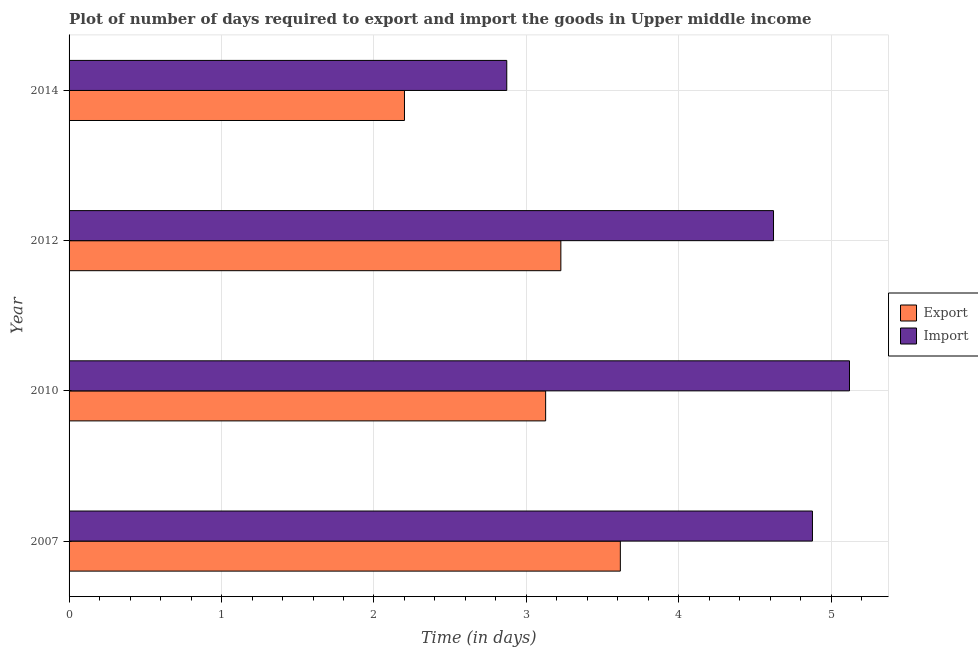How many different coloured bars are there?
Provide a short and direct response. 2. How many groups of bars are there?
Give a very brief answer. 4. Are the number of bars per tick equal to the number of legend labels?
Offer a very short reply. Yes. How many bars are there on the 1st tick from the bottom?
Your response must be concise. 2. What is the label of the 4th group of bars from the top?
Keep it short and to the point. 2007. In how many cases, is the number of bars for a given year not equal to the number of legend labels?
Make the answer very short. 0. What is the time required to import in 2010?
Provide a succinct answer. 5.12. Across all years, what is the maximum time required to import?
Your response must be concise. 5.12. Across all years, what is the minimum time required to import?
Ensure brevity in your answer.  2.87. What is the total time required to import in the graph?
Offer a terse response. 17.49. What is the difference between the time required to export in 2010 and that in 2012?
Offer a terse response. -0.1. What is the difference between the time required to import in 2007 and the time required to export in 2012?
Make the answer very short. 1.65. What is the average time required to export per year?
Make the answer very short. 3.04. In the year 2014, what is the difference between the time required to import and time required to export?
Ensure brevity in your answer.  0.67. What is the ratio of the time required to export in 2010 to that in 2014?
Offer a terse response. 1.42. What is the difference between the highest and the second highest time required to import?
Make the answer very short. 0.24. What is the difference between the highest and the lowest time required to import?
Give a very brief answer. 2.25. In how many years, is the time required to import greater than the average time required to import taken over all years?
Ensure brevity in your answer.  3. Is the sum of the time required to export in 2010 and 2012 greater than the maximum time required to import across all years?
Offer a very short reply. Yes. What does the 1st bar from the top in 2007 represents?
Give a very brief answer. Import. What does the 1st bar from the bottom in 2007 represents?
Give a very brief answer. Export. How many bars are there?
Provide a succinct answer. 8. Are all the bars in the graph horizontal?
Your answer should be compact. Yes. How many years are there in the graph?
Provide a succinct answer. 4. What is the difference between two consecutive major ticks on the X-axis?
Offer a terse response. 1. How many legend labels are there?
Your answer should be compact. 2. How are the legend labels stacked?
Offer a terse response. Vertical. What is the title of the graph?
Provide a succinct answer. Plot of number of days required to export and import the goods in Upper middle income. What is the label or title of the X-axis?
Ensure brevity in your answer.  Time (in days). What is the Time (in days) of Export in 2007?
Give a very brief answer. 3.62. What is the Time (in days) in Import in 2007?
Give a very brief answer. 4.88. What is the Time (in days) of Export in 2010?
Your answer should be very brief. 3.13. What is the Time (in days) of Import in 2010?
Make the answer very short. 5.12. What is the Time (in days) in Export in 2012?
Provide a short and direct response. 3.23. What is the Time (in days) in Import in 2012?
Keep it short and to the point. 4.62. What is the Time (in days) in Import in 2014?
Provide a short and direct response. 2.87. Across all years, what is the maximum Time (in days) of Export?
Keep it short and to the point. 3.62. Across all years, what is the maximum Time (in days) of Import?
Offer a terse response. 5.12. Across all years, what is the minimum Time (in days) of Export?
Provide a succinct answer. 2.2. Across all years, what is the minimum Time (in days) in Import?
Provide a succinct answer. 2.87. What is the total Time (in days) in Export in the graph?
Make the answer very short. 12.17. What is the total Time (in days) of Import in the graph?
Provide a succinct answer. 17.49. What is the difference between the Time (in days) of Export in 2007 and that in 2010?
Keep it short and to the point. 0.49. What is the difference between the Time (in days) of Import in 2007 and that in 2010?
Offer a very short reply. -0.24. What is the difference between the Time (in days) of Export in 2007 and that in 2012?
Your answer should be compact. 0.39. What is the difference between the Time (in days) in Import in 2007 and that in 2012?
Your answer should be compact. 0.26. What is the difference between the Time (in days) in Export in 2007 and that in 2014?
Make the answer very short. 1.42. What is the difference between the Time (in days) of Import in 2007 and that in 2014?
Give a very brief answer. 2. What is the difference between the Time (in days) in Export in 2010 and that in 2012?
Your answer should be compact. -0.1. What is the difference between the Time (in days) of Import in 2010 and that in 2012?
Your answer should be very brief. 0.5. What is the difference between the Time (in days) of Export in 2010 and that in 2014?
Provide a short and direct response. 0.93. What is the difference between the Time (in days) of Import in 2010 and that in 2014?
Give a very brief answer. 2.25. What is the difference between the Time (in days) of Export in 2012 and that in 2014?
Offer a very short reply. 1.03. What is the difference between the Time (in days) of Import in 2012 and that in 2014?
Make the answer very short. 1.75. What is the difference between the Time (in days) of Export in 2007 and the Time (in days) of Import in 2010?
Your response must be concise. -1.5. What is the difference between the Time (in days) of Export in 2007 and the Time (in days) of Import in 2012?
Ensure brevity in your answer.  -1. What is the difference between the Time (in days) in Export in 2007 and the Time (in days) in Import in 2014?
Your response must be concise. 0.74. What is the difference between the Time (in days) of Export in 2010 and the Time (in days) of Import in 2012?
Offer a terse response. -1.49. What is the difference between the Time (in days) of Export in 2010 and the Time (in days) of Import in 2014?
Your answer should be compact. 0.26. What is the difference between the Time (in days) of Export in 2012 and the Time (in days) of Import in 2014?
Provide a short and direct response. 0.35. What is the average Time (in days) of Export per year?
Ensure brevity in your answer.  3.04. What is the average Time (in days) of Import per year?
Offer a very short reply. 4.37. In the year 2007, what is the difference between the Time (in days) of Export and Time (in days) of Import?
Offer a very short reply. -1.26. In the year 2010, what is the difference between the Time (in days) in Export and Time (in days) in Import?
Your answer should be compact. -1.99. In the year 2012, what is the difference between the Time (in days) of Export and Time (in days) of Import?
Offer a terse response. -1.39. In the year 2014, what is the difference between the Time (in days) in Export and Time (in days) in Import?
Your answer should be very brief. -0.67. What is the ratio of the Time (in days) in Export in 2007 to that in 2010?
Ensure brevity in your answer.  1.16. What is the ratio of the Time (in days) in Import in 2007 to that in 2010?
Make the answer very short. 0.95. What is the ratio of the Time (in days) in Export in 2007 to that in 2012?
Make the answer very short. 1.12. What is the ratio of the Time (in days) in Import in 2007 to that in 2012?
Offer a very short reply. 1.06. What is the ratio of the Time (in days) of Export in 2007 to that in 2014?
Make the answer very short. 1.64. What is the ratio of the Time (in days) of Import in 2007 to that in 2014?
Your answer should be compact. 1.7. What is the ratio of the Time (in days) of Export in 2010 to that in 2012?
Make the answer very short. 0.97. What is the ratio of the Time (in days) in Import in 2010 to that in 2012?
Provide a succinct answer. 1.11. What is the ratio of the Time (in days) of Export in 2010 to that in 2014?
Your answer should be very brief. 1.42. What is the ratio of the Time (in days) of Import in 2010 to that in 2014?
Keep it short and to the point. 1.78. What is the ratio of the Time (in days) of Export in 2012 to that in 2014?
Your response must be concise. 1.47. What is the ratio of the Time (in days) of Import in 2012 to that in 2014?
Keep it short and to the point. 1.61. What is the difference between the highest and the second highest Time (in days) in Export?
Ensure brevity in your answer.  0.39. What is the difference between the highest and the second highest Time (in days) in Import?
Your answer should be very brief. 0.24. What is the difference between the highest and the lowest Time (in days) of Export?
Offer a very short reply. 1.42. What is the difference between the highest and the lowest Time (in days) in Import?
Keep it short and to the point. 2.25. 